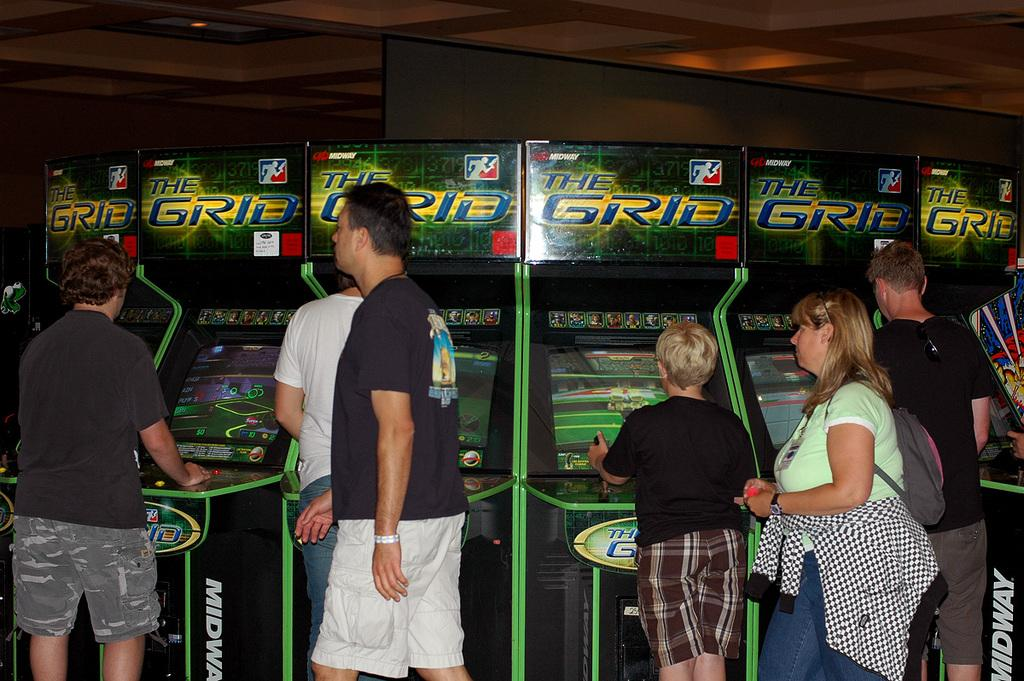Who is present in the image? There are people in the image. What are some of the people doing in the image? Some of the people are playing games. What can be seen on the screens in the image? The screens are visible in the image, but their content is not specified. What is the title of the railway in the image? There is no railway present in the image, so there is no title to be mentioned. 